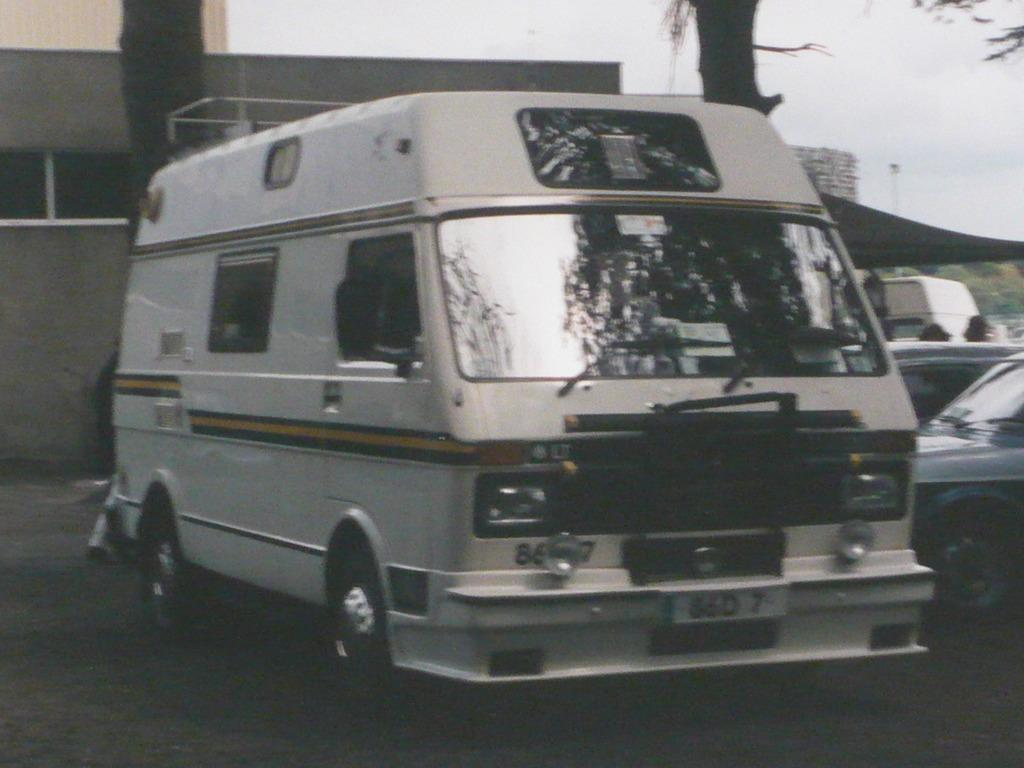What can be seen in the front of the image? There are vehicles in the front of the image. What structure is located on the left side of the image? There is a building on the left side of the image. What type of vegetation is in the middle of the image? There are trees in the middle of the image. What is visible at the right top of the image? The sky is visible at the right top of the image. How many children are holding spoons in the image? There are no children or spoons present in the image. What type of form does the building have in the image? The provided facts do not mention the form or shape of the building, so we cannot answer this question based on the given information. 